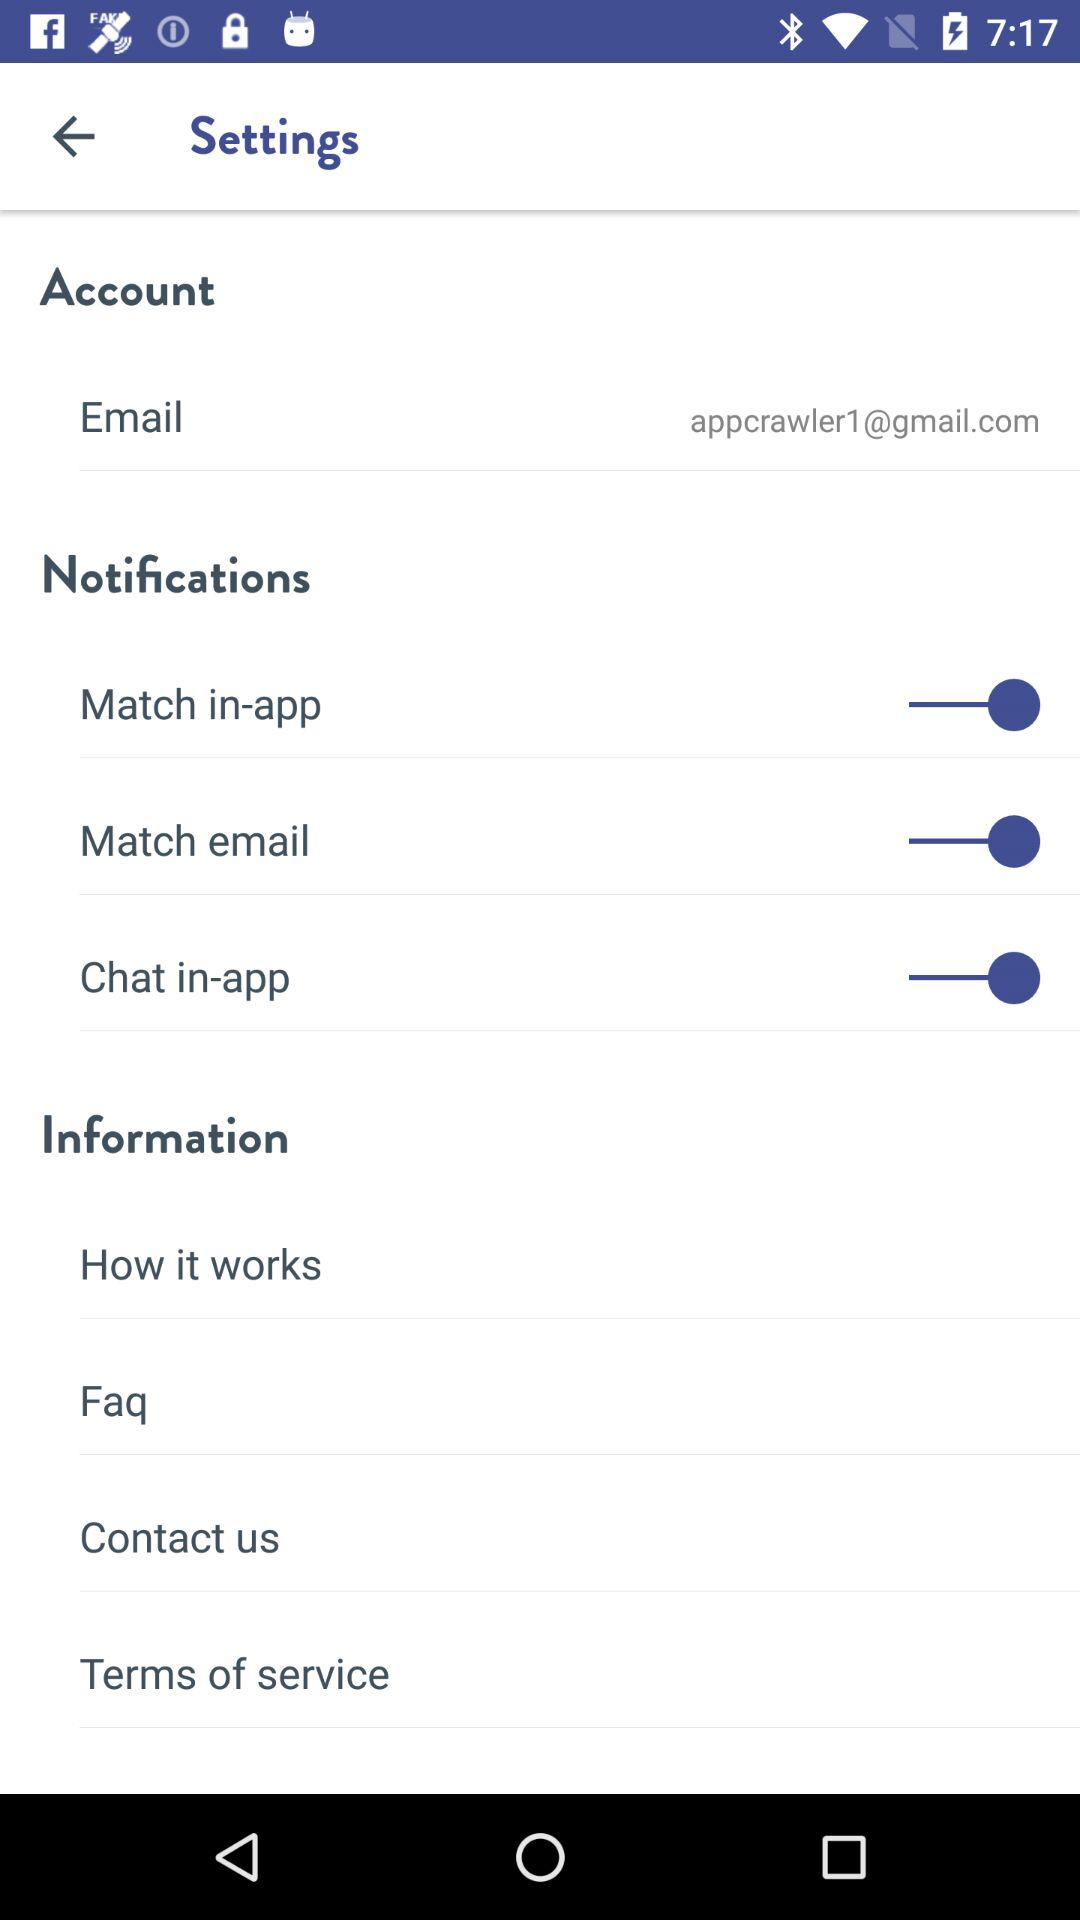What is the status of the "Match email"? The status is "on". 